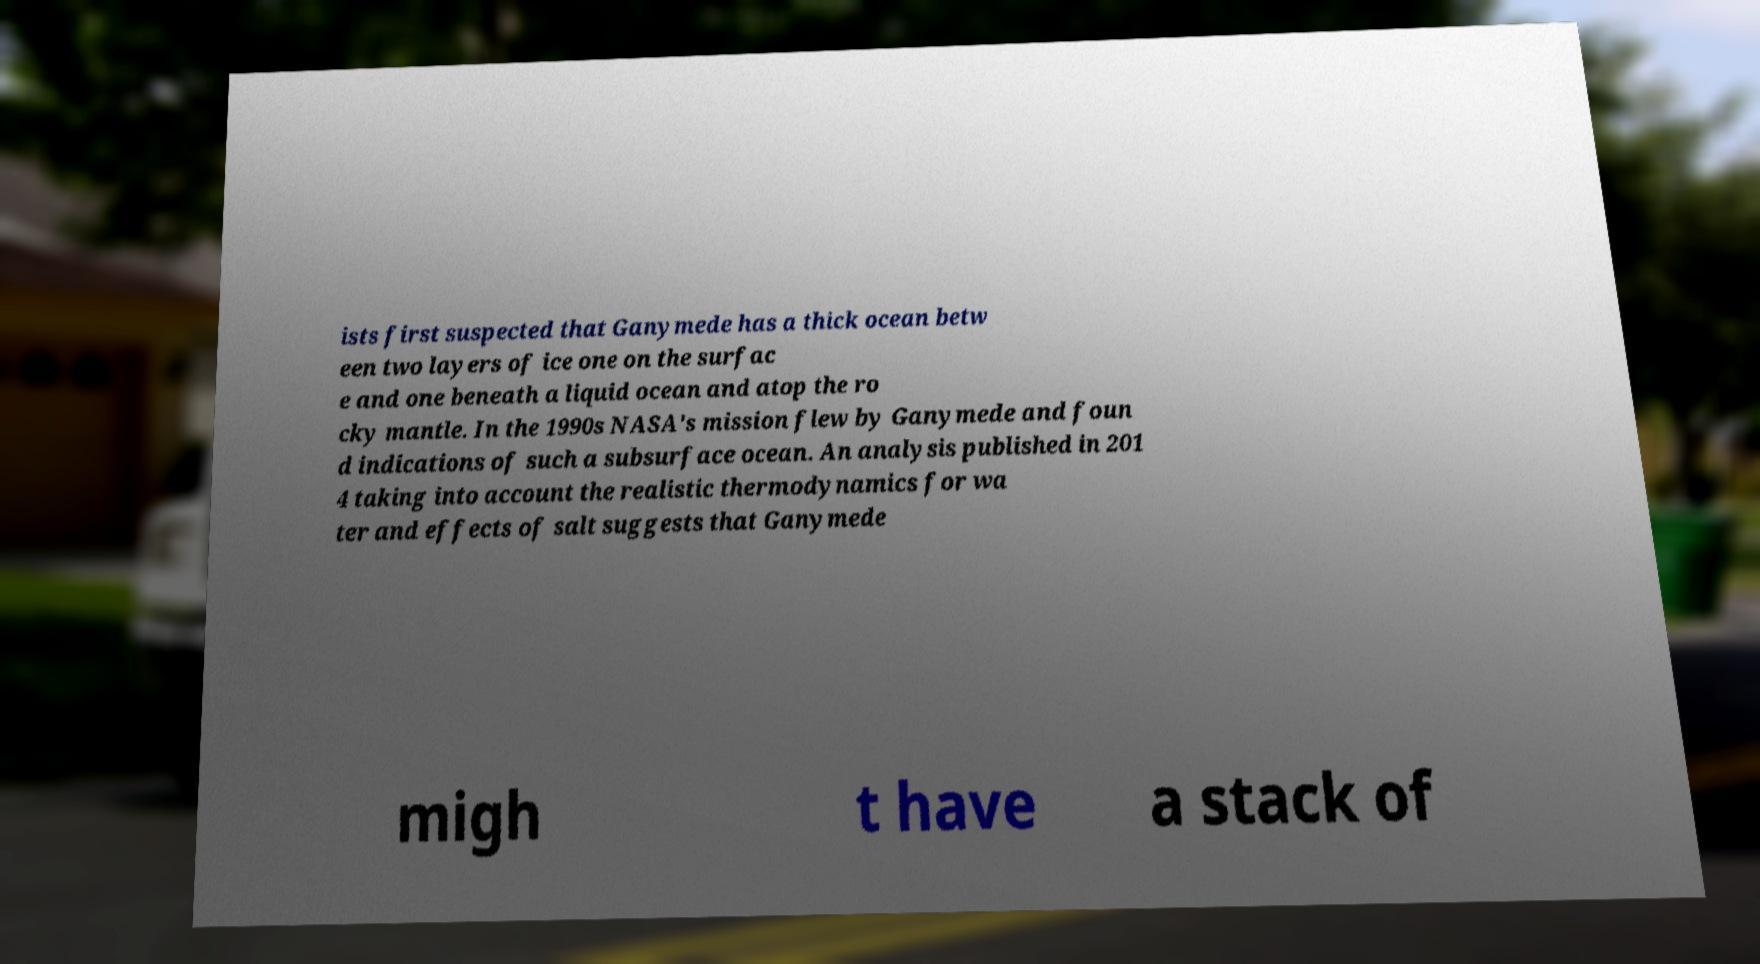For documentation purposes, I need the text within this image transcribed. Could you provide that? ists first suspected that Ganymede has a thick ocean betw een two layers of ice one on the surfac e and one beneath a liquid ocean and atop the ro cky mantle. In the 1990s NASA's mission flew by Ganymede and foun d indications of such a subsurface ocean. An analysis published in 201 4 taking into account the realistic thermodynamics for wa ter and effects of salt suggests that Ganymede migh t have a stack of 